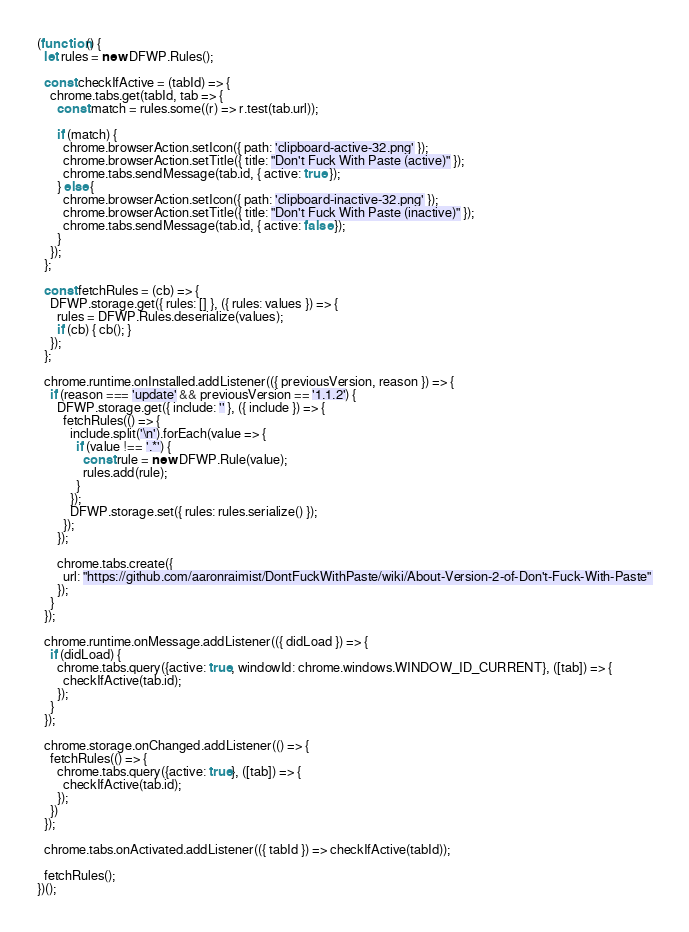Convert code to text. <code><loc_0><loc_0><loc_500><loc_500><_JavaScript_>(function() {
  let rules = new DFWP.Rules();

  const checkIfActive = (tabId) => {
    chrome.tabs.get(tabId, tab => {
      const match = rules.some((r) => r.test(tab.url));

      if (match) {
        chrome.browserAction.setIcon({ path: 'clipboard-active-32.png' });
        chrome.browserAction.setTitle({ title: "Don't Fuck With Paste (active)" });
        chrome.tabs.sendMessage(tab.id, { active: true });
      } else {
        chrome.browserAction.setIcon({ path: 'clipboard-inactive-32.png' });
        chrome.browserAction.setTitle({ title: "Don't Fuck With Paste (inactive)" });
        chrome.tabs.sendMessage(tab.id, { active: false });
      }
    });
  };

  const fetchRules = (cb) => {
    DFWP.storage.get({ rules: [] }, ({ rules: values }) => {
      rules = DFWP.Rules.deserialize(values);
      if (cb) { cb(); }
    });
  };

  chrome.runtime.onInstalled.addListener(({ previousVersion, reason }) => {
    if (reason === 'update' && previousVersion == '1.1.2') {
      DFWP.storage.get({ include: '' }, ({ include }) => {
        fetchRules(() => {
          include.split('\n').forEach(value => {
            if (value !== '.*') {
              const rule = new DFWP.Rule(value);
              rules.add(rule);
            }
          });
          DFWP.storage.set({ rules: rules.serialize() });
        });
      });

      chrome.tabs.create({
        url: "https://github.com/aaronraimist/DontFuckWithPaste/wiki/About-Version-2-of-Don't-Fuck-With-Paste"
      });
    }
  });

  chrome.runtime.onMessage.addListener(({ didLoad }) => {
    if (didLoad) {
      chrome.tabs.query({active: true, windowId: chrome.windows.WINDOW_ID_CURRENT}, ([tab]) => {
        checkIfActive(tab.id);
      });
    }
  });

  chrome.storage.onChanged.addListener(() => {
    fetchRules(() => {
      chrome.tabs.query({active: true}, ([tab]) => {
        checkIfActive(tab.id);
      });
    })
  });

  chrome.tabs.onActivated.addListener(({ tabId }) => checkIfActive(tabId));

  fetchRules();
})();
</code> 